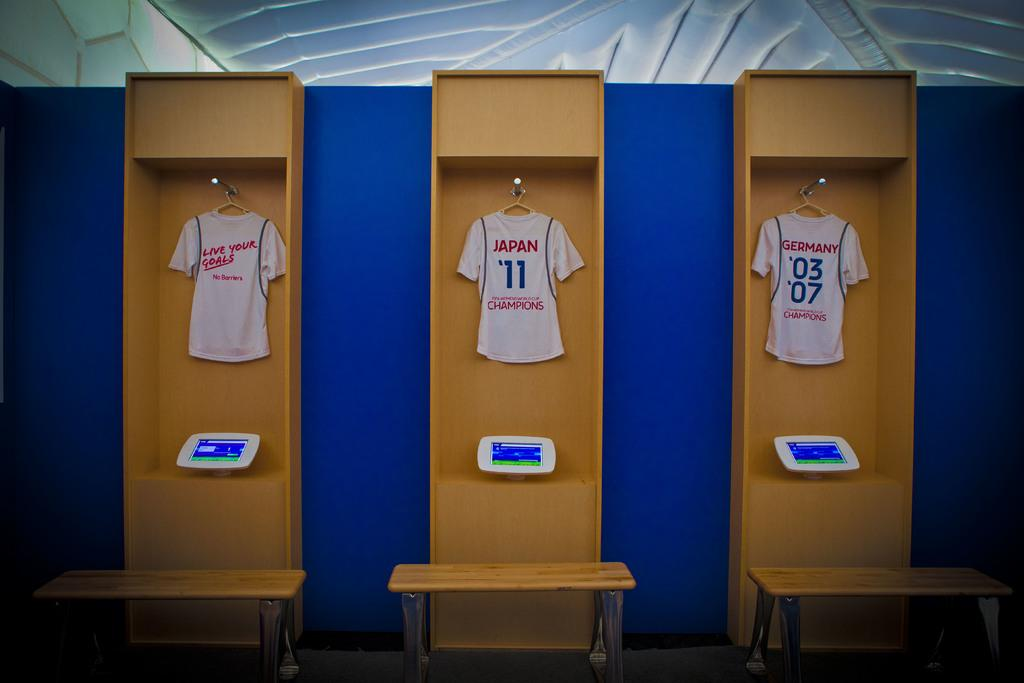<image>
Describe the image concisely. Three locker areas with hanging jerseys in each cabinet with the center jersey saying Japan '11 Champions 